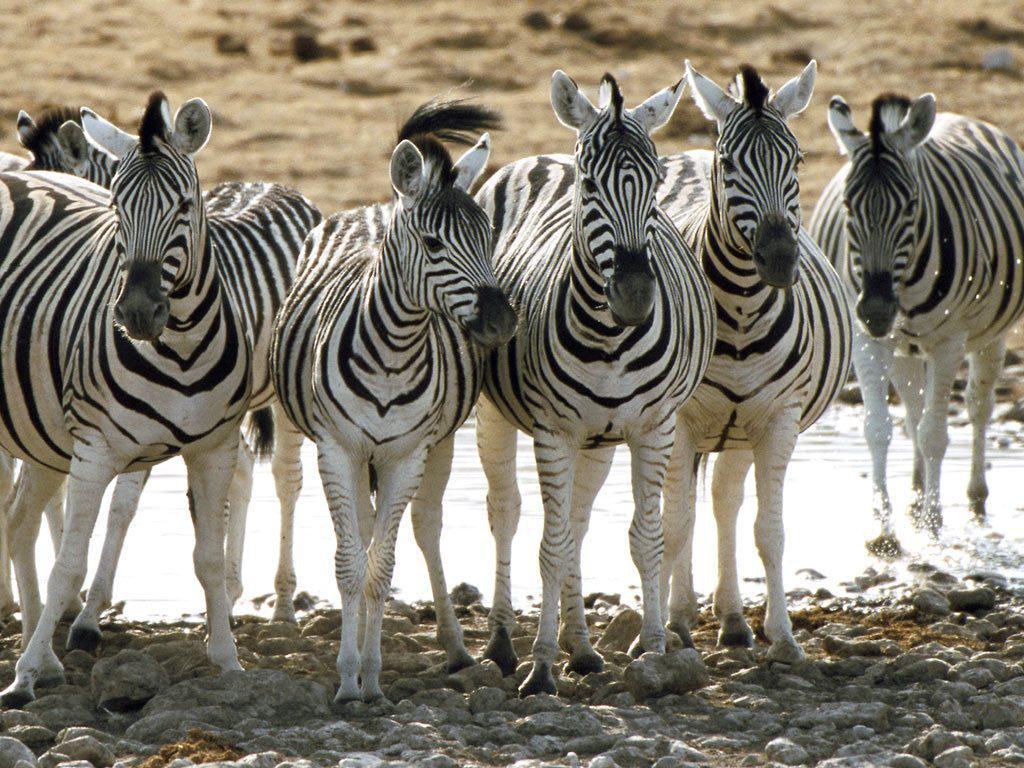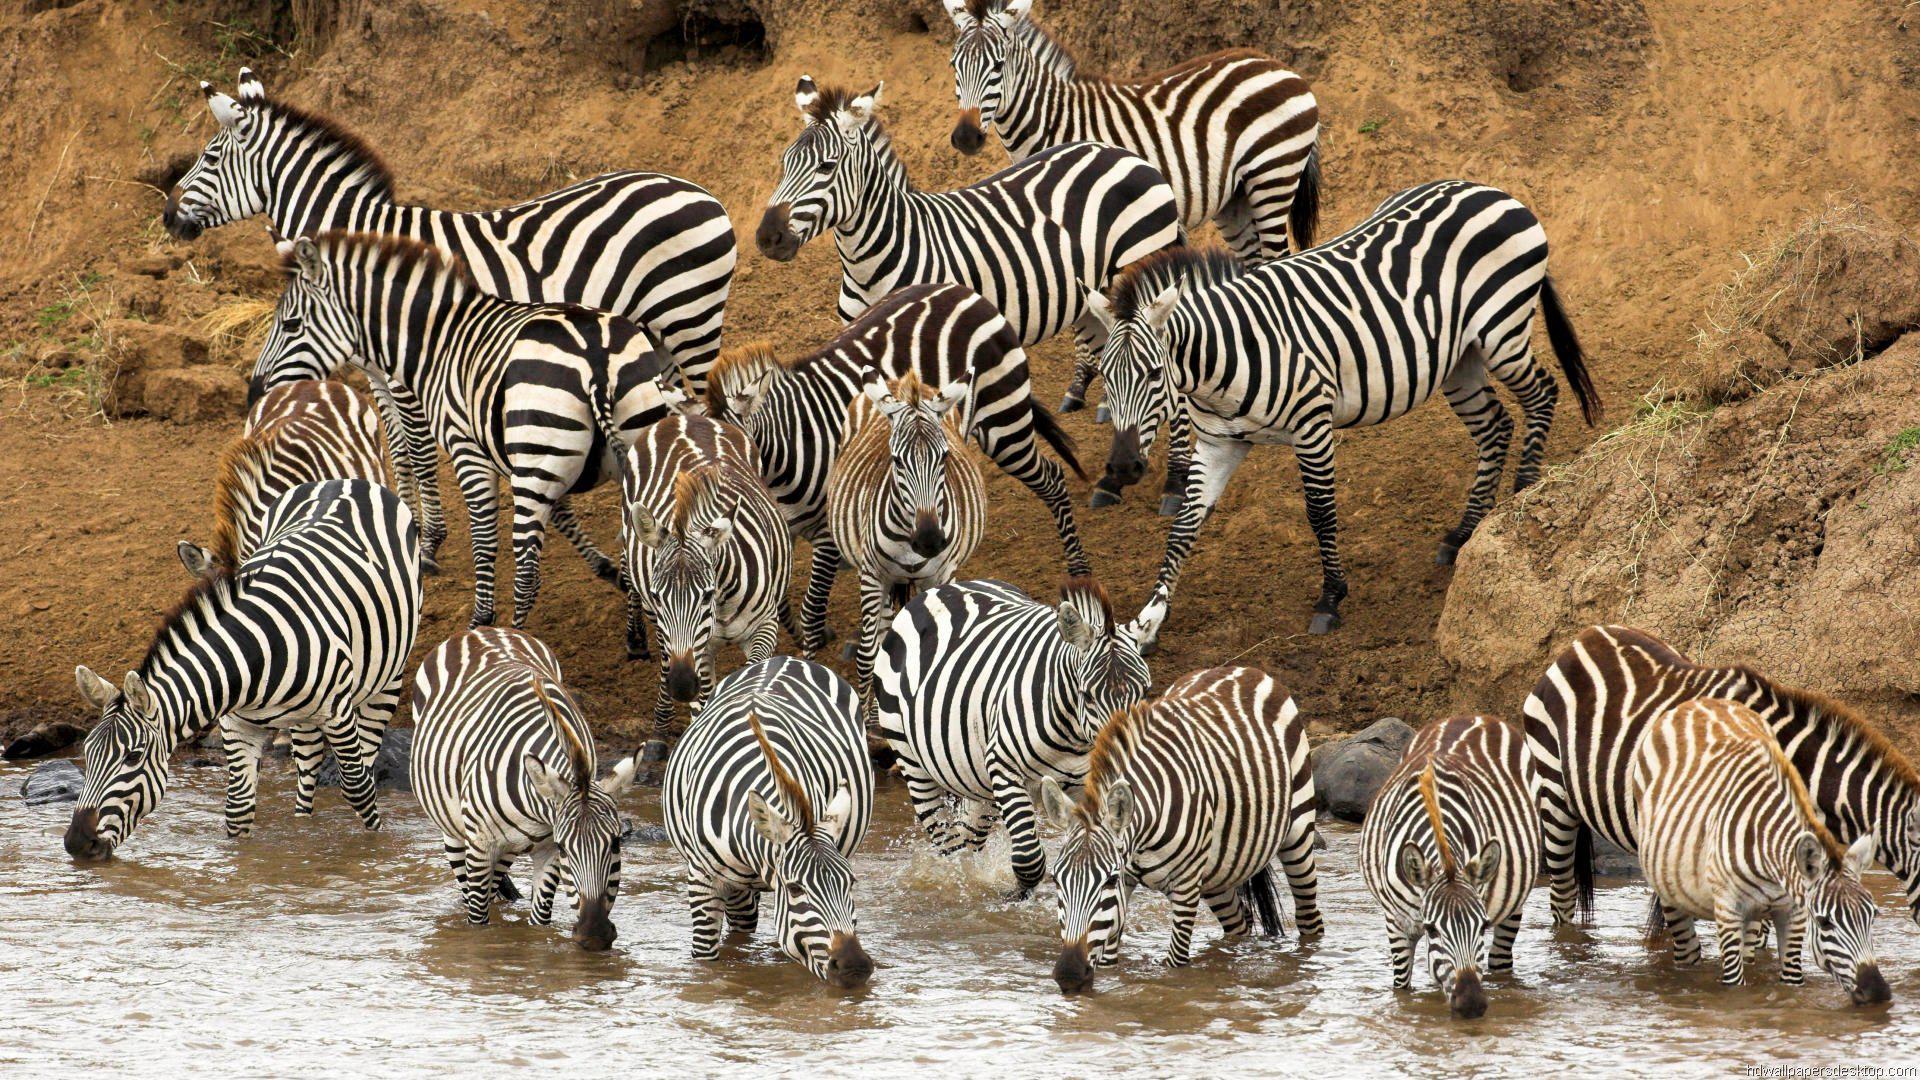The first image is the image on the left, the second image is the image on the right. For the images displayed, is the sentence "The animals in both images are near a body of water." factually correct? Answer yes or no. Yes. The first image is the image on the left, the second image is the image on the right. Assess this claim about the two images: "One image shows a row of zebras standing in water with heads lowered to drink.". Correct or not? Answer yes or no. Yes. 